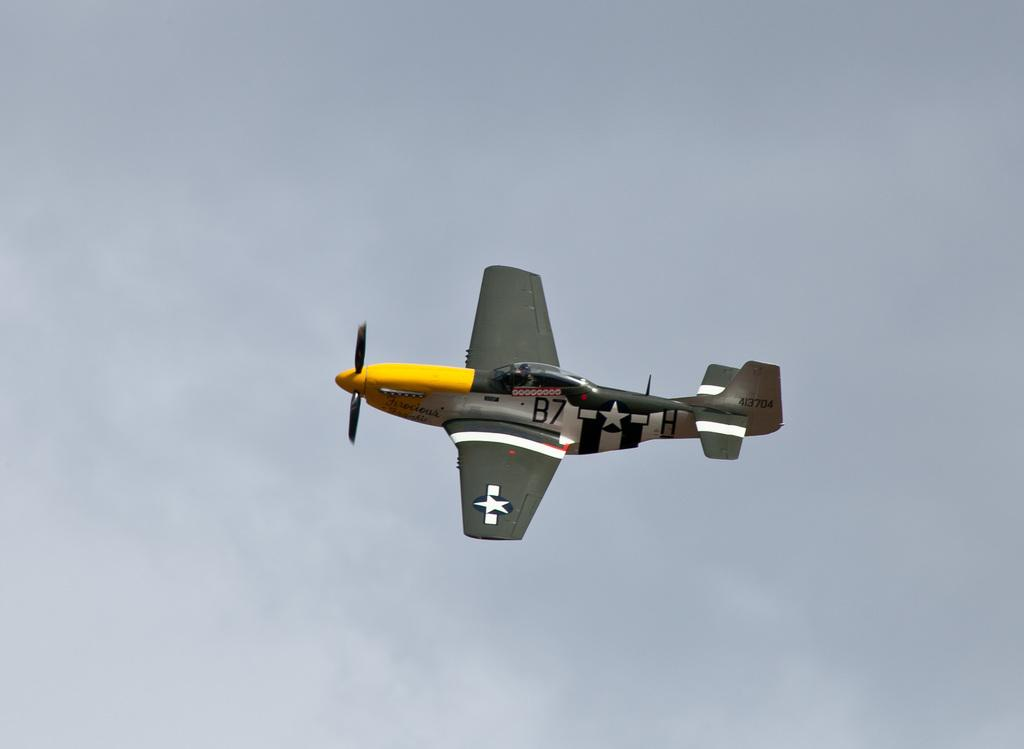<image>
Render a clear and concise summary of the photo. A small airplane has the number B7 on it and has a yellow nose. 